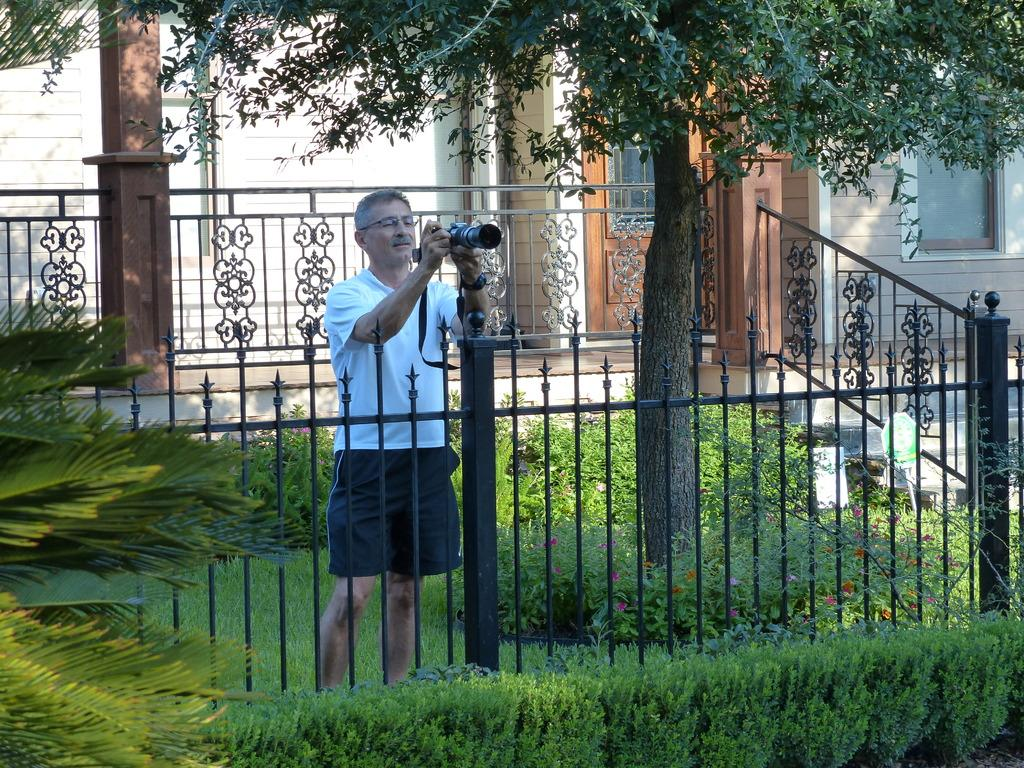What is the man in the image holding? The man is holding a camera in the image. What can be seen in the background of the image? There is a black fence, plants, grass, and a building with a door and window visible in the image. What architectural feature is present in front of the building? There is a pillar in front of the building in the image. What type of vegetation is in front of the building? There is a tree in front of the building in the image. What is the daughter doing with the cow at the camp in the image? There is no daughter, cow, or camp present in the image. 